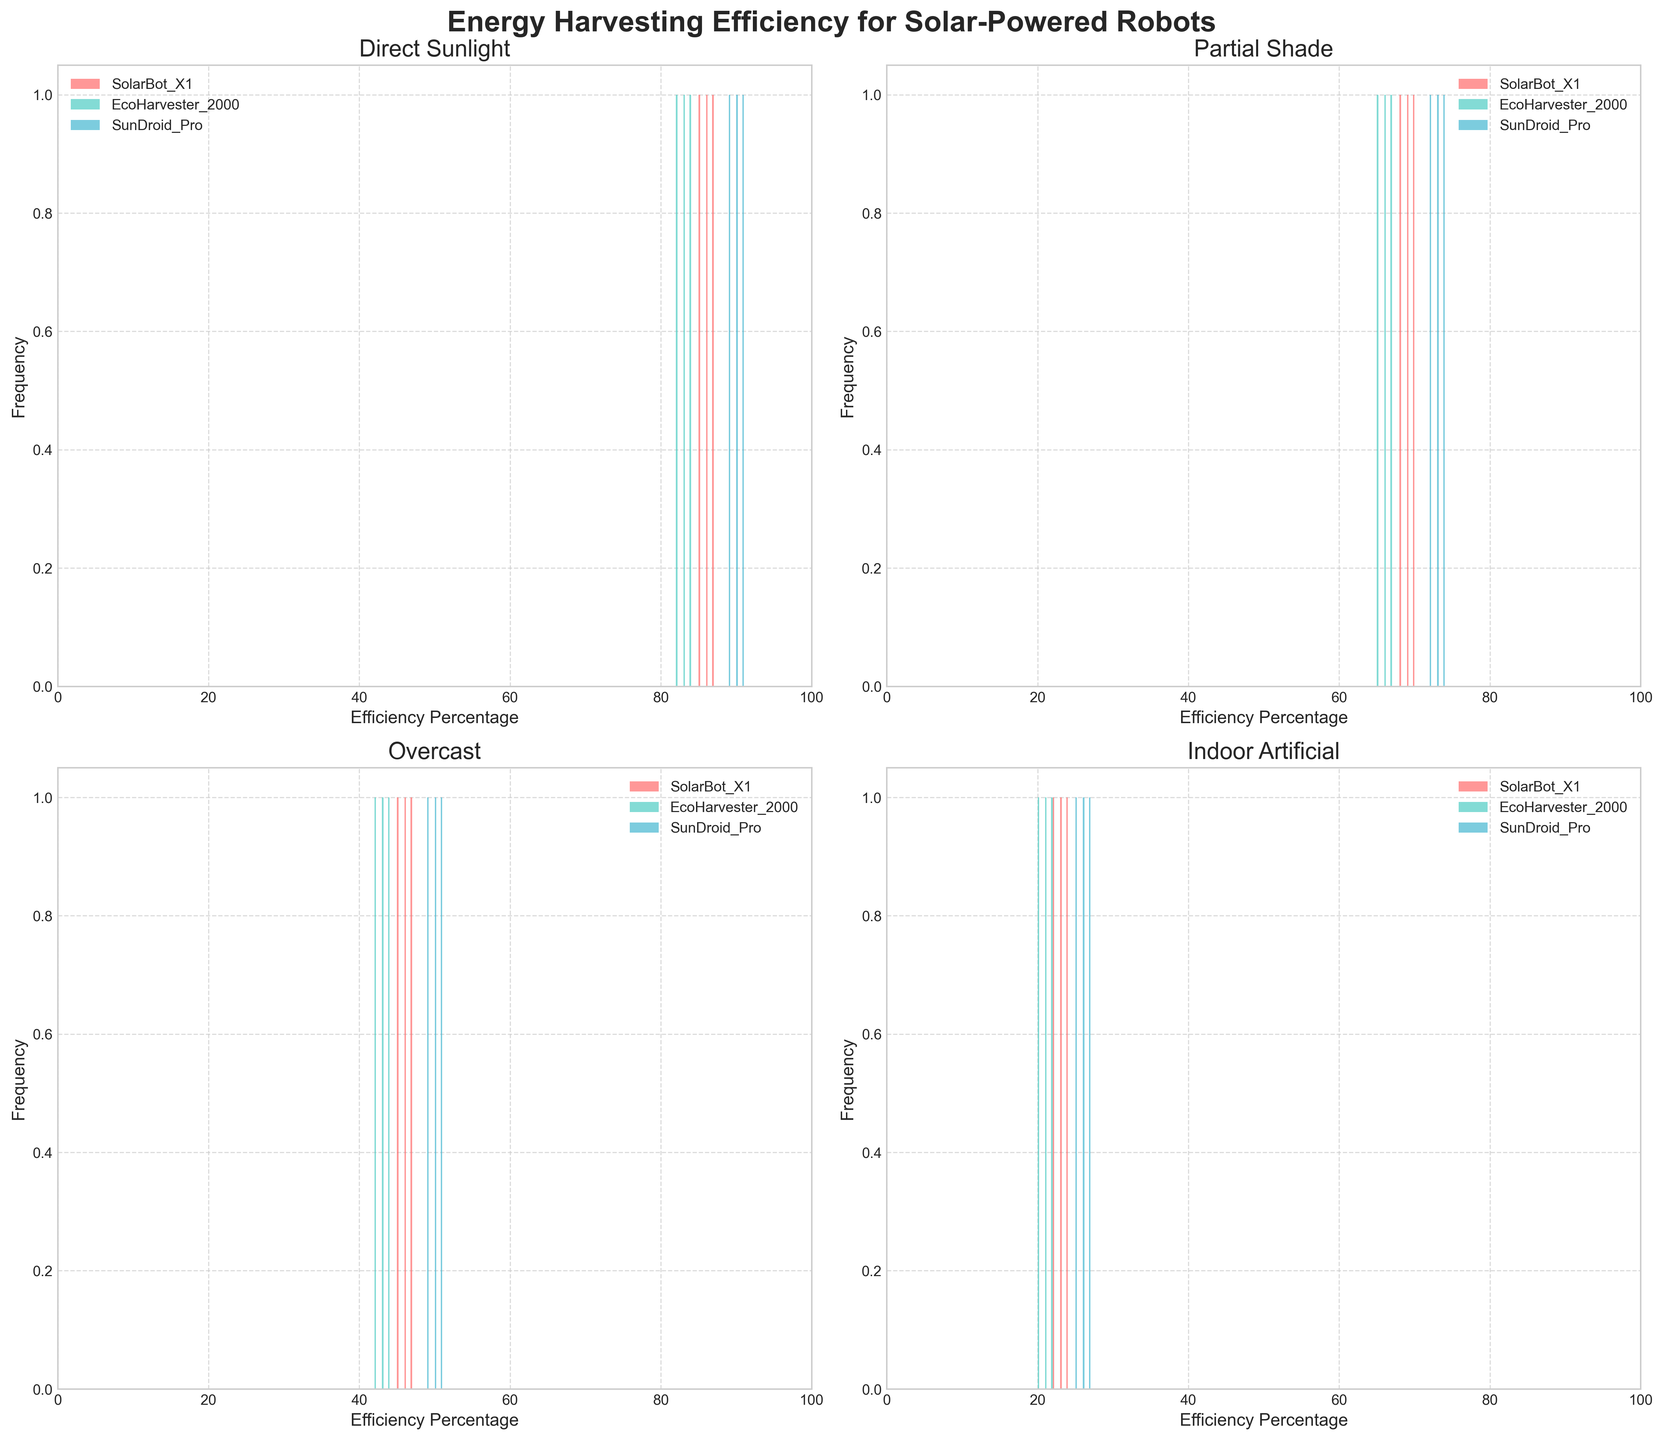Which lighting condition shows the highest energy harvesting efficiency for SolarBot X1? First, locate the subplot corresponding to "Direct Sunlight". In this subplot, observe the peak (highest bar in the histogram) of SolarBot X1, which shows the highest efficiency around 86-87%.
Answer: Direct Sunlight What is the efficiency range for EcoHarvester 2000 under Overcast conditions? Find the subplot titled "Overcast". Look at the bins for EcoHarvester 2000 to find the lowest and highest efficiency values. The efficiencies cover the range from 42% to 44%.
Answer: 42% to 44% How does the efficiency distribution of SunDroid Pro differ between Direct Sunlight and Partial Shade? Compare the subplots for "Direct Sunlight" and "Partial Shade". SunDroid Pro's efficiency in Direct Sunlight ranges from 89% to 91%, while in Partial Shade, it ranges from 72% to 74%.
Answer: Direct Sunlight: 89%-91%, Partial Shade: 72%-74% Which robot model has the widest efficiency distribution range under Indoor Artificial lighting? In the subplot for "Indoor Artificial", examine the spread of the histograms for each robot model. SunDroid Pro shows the widest distribution from 25% to 27%.
Answer: SunDroid Pro How many efficiency percentage bins are used in each histogram? Each histogram is plotted with bins. Count the number of bins in one of the histograms to determine the bin count. There are 10 bins.
Answer: 10 Under Overcast conditions, which robot has the median efficiency and what is that value? Locate the "Overcast" subplot and focus on the histogram centers for each robot. For EcoHarvester 2000, the middle value within the 42%-44% range is 43%.
Answer: EcoHarvester 2000, 43% What is the graphical difference between robots' efficiency under Direct Sunlight and Indoor Artificial light? Compare the overall spread and height of the histogram bars between "Direct Sunlight" and "Indoor Artificial". Direct Sunlight has a tighter clustering at higher efficiencies (82-91%), while Indoor Artificial shows lower efficiencies (20-27%) with less clustering.
Answer: Tighter clustering in Direct Sunlight, lower and less clustered in Indoor Artificial Which lighting condition shows the least variation in efficiency for SunDroid Pro? Examine the spread of the histograms for SunDroid Pro across conditions. The "Overcast" condition has the narrowest range from 49% to 51%.
Answer: Overcast What is the frequency of SolarBot X1 achieving an efficiency of 24% under Indoor Artificial light? In the "Indoor Artificial" subplot, identify the bar corresponding to 24% for SolarBot X1 and read the frequency. The frequency is 1.
Answer: 1 